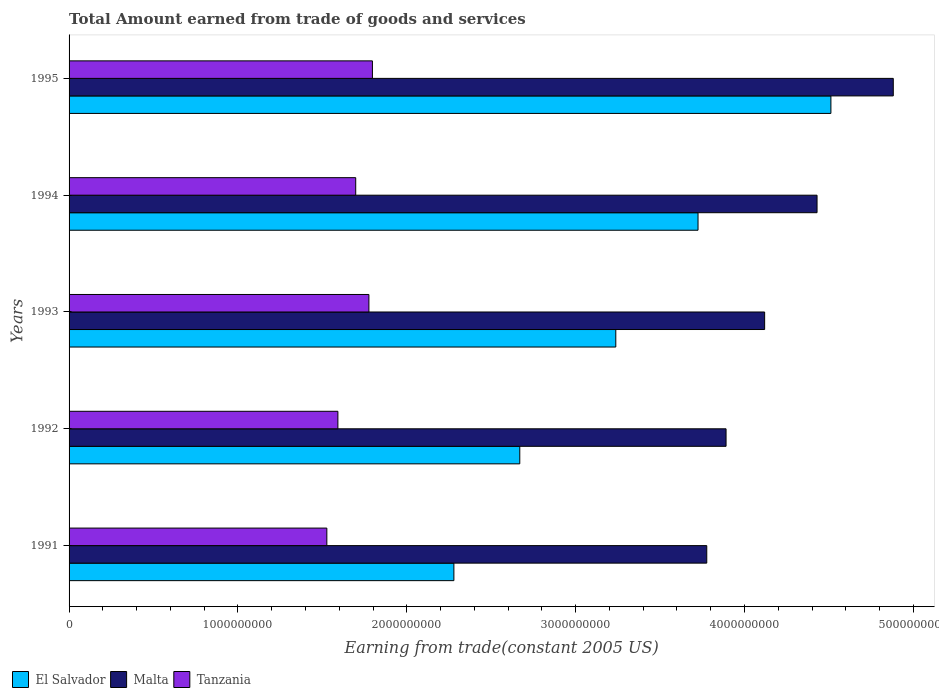How many different coloured bars are there?
Your answer should be very brief. 3. Are the number of bars per tick equal to the number of legend labels?
Offer a very short reply. Yes. What is the total amount earned by trading goods and services in El Salvador in 1992?
Provide a short and direct response. 2.67e+09. Across all years, what is the maximum total amount earned by trading goods and services in El Salvador?
Provide a succinct answer. 4.51e+09. Across all years, what is the minimum total amount earned by trading goods and services in Malta?
Provide a short and direct response. 3.78e+09. In which year was the total amount earned by trading goods and services in Malta minimum?
Offer a very short reply. 1991. What is the total total amount earned by trading goods and services in Malta in the graph?
Ensure brevity in your answer.  2.11e+1. What is the difference between the total amount earned by trading goods and services in El Salvador in 1993 and that in 1995?
Provide a succinct answer. -1.27e+09. What is the difference between the total amount earned by trading goods and services in El Salvador in 1991 and the total amount earned by trading goods and services in Tanzania in 1995?
Give a very brief answer. 4.82e+08. What is the average total amount earned by trading goods and services in Tanzania per year?
Provide a succinct answer. 1.68e+09. In the year 1991, what is the difference between the total amount earned by trading goods and services in Tanzania and total amount earned by trading goods and services in Malta?
Give a very brief answer. -2.25e+09. In how many years, is the total amount earned by trading goods and services in Malta greater than 4400000000 US$?
Keep it short and to the point. 2. What is the ratio of the total amount earned by trading goods and services in Malta in 1992 to that in 1993?
Your answer should be very brief. 0.94. What is the difference between the highest and the second highest total amount earned by trading goods and services in El Salvador?
Offer a very short reply. 7.87e+08. What is the difference between the highest and the lowest total amount earned by trading goods and services in El Salvador?
Your response must be concise. 2.23e+09. What does the 1st bar from the top in 1992 represents?
Provide a succinct answer. Tanzania. What does the 2nd bar from the bottom in 1993 represents?
Give a very brief answer. Malta. Are all the bars in the graph horizontal?
Your response must be concise. Yes. Does the graph contain any zero values?
Ensure brevity in your answer.  No. How many legend labels are there?
Offer a terse response. 3. How are the legend labels stacked?
Provide a short and direct response. Horizontal. What is the title of the graph?
Offer a very short reply. Total Amount earned from trade of goods and services. Does "South Sudan" appear as one of the legend labels in the graph?
Offer a very short reply. No. What is the label or title of the X-axis?
Offer a terse response. Earning from trade(constant 2005 US). What is the label or title of the Y-axis?
Your answer should be compact. Years. What is the Earning from trade(constant 2005 US) of El Salvador in 1991?
Offer a very short reply. 2.28e+09. What is the Earning from trade(constant 2005 US) in Malta in 1991?
Your answer should be compact. 3.78e+09. What is the Earning from trade(constant 2005 US) of Tanzania in 1991?
Offer a very short reply. 1.53e+09. What is the Earning from trade(constant 2005 US) of El Salvador in 1992?
Your answer should be compact. 2.67e+09. What is the Earning from trade(constant 2005 US) of Malta in 1992?
Your answer should be compact. 3.89e+09. What is the Earning from trade(constant 2005 US) in Tanzania in 1992?
Your answer should be very brief. 1.59e+09. What is the Earning from trade(constant 2005 US) in El Salvador in 1993?
Ensure brevity in your answer.  3.24e+09. What is the Earning from trade(constant 2005 US) in Malta in 1993?
Your answer should be very brief. 4.12e+09. What is the Earning from trade(constant 2005 US) of Tanzania in 1993?
Offer a terse response. 1.78e+09. What is the Earning from trade(constant 2005 US) in El Salvador in 1994?
Give a very brief answer. 3.72e+09. What is the Earning from trade(constant 2005 US) of Malta in 1994?
Offer a very short reply. 4.43e+09. What is the Earning from trade(constant 2005 US) in Tanzania in 1994?
Ensure brevity in your answer.  1.70e+09. What is the Earning from trade(constant 2005 US) of El Salvador in 1995?
Provide a short and direct response. 4.51e+09. What is the Earning from trade(constant 2005 US) of Malta in 1995?
Make the answer very short. 4.88e+09. What is the Earning from trade(constant 2005 US) of Tanzania in 1995?
Provide a succinct answer. 1.80e+09. Across all years, what is the maximum Earning from trade(constant 2005 US) of El Salvador?
Your response must be concise. 4.51e+09. Across all years, what is the maximum Earning from trade(constant 2005 US) of Malta?
Make the answer very short. 4.88e+09. Across all years, what is the maximum Earning from trade(constant 2005 US) of Tanzania?
Offer a terse response. 1.80e+09. Across all years, what is the minimum Earning from trade(constant 2005 US) in El Salvador?
Offer a terse response. 2.28e+09. Across all years, what is the minimum Earning from trade(constant 2005 US) of Malta?
Make the answer very short. 3.78e+09. Across all years, what is the minimum Earning from trade(constant 2005 US) in Tanzania?
Your response must be concise. 1.53e+09. What is the total Earning from trade(constant 2005 US) in El Salvador in the graph?
Offer a terse response. 1.64e+1. What is the total Earning from trade(constant 2005 US) in Malta in the graph?
Offer a terse response. 2.11e+1. What is the total Earning from trade(constant 2005 US) in Tanzania in the graph?
Make the answer very short. 8.39e+09. What is the difference between the Earning from trade(constant 2005 US) in El Salvador in 1991 and that in 1992?
Ensure brevity in your answer.  -3.90e+08. What is the difference between the Earning from trade(constant 2005 US) in Malta in 1991 and that in 1992?
Your response must be concise. -1.14e+08. What is the difference between the Earning from trade(constant 2005 US) of Tanzania in 1991 and that in 1992?
Provide a short and direct response. -6.54e+07. What is the difference between the Earning from trade(constant 2005 US) in El Salvador in 1991 and that in 1993?
Ensure brevity in your answer.  -9.59e+08. What is the difference between the Earning from trade(constant 2005 US) of Malta in 1991 and that in 1993?
Keep it short and to the point. -3.43e+08. What is the difference between the Earning from trade(constant 2005 US) in Tanzania in 1991 and that in 1993?
Keep it short and to the point. -2.49e+08. What is the difference between the Earning from trade(constant 2005 US) in El Salvador in 1991 and that in 1994?
Your answer should be compact. -1.45e+09. What is the difference between the Earning from trade(constant 2005 US) in Malta in 1991 and that in 1994?
Provide a short and direct response. -6.53e+08. What is the difference between the Earning from trade(constant 2005 US) in Tanzania in 1991 and that in 1994?
Offer a very short reply. -1.71e+08. What is the difference between the Earning from trade(constant 2005 US) of El Salvador in 1991 and that in 1995?
Offer a terse response. -2.23e+09. What is the difference between the Earning from trade(constant 2005 US) of Malta in 1991 and that in 1995?
Keep it short and to the point. -1.10e+09. What is the difference between the Earning from trade(constant 2005 US) of Tanzania in 1991 and that in 1995?
Offer a terse response. -2.70e+08. What is the difference between the Earning from trade(constant 2005 US) of El Salvador in 1992 and that in 1993?
Give a very brief answer. -5.69e+08. What is the difference between the Earning from trade(constant 2005 US) of Malta in 1992 and that in 1993?
Offer a terse response. -2.29e+08. What is the difference between the Earning from trade(constant 2005 US) in Tanzania in 1992 and that in 1993?
Make the answer very short. -1.84e+08. What is the difference between the Earning from trade(constant 2005 US) in El Salvador in 1992 and that in 1994?
Make the answer very short. -1.06e+09. What is the difference between the Earning from trade(constant 2005 US) of Malta in 1992 and that in 1994?
Your answer should be compact. -5.39e+08. What is the difference between the Earning from trade(constant 2005 US) in Tanzania in 1992 and that in 1994?
Provide a short and direct response. -1.06e+08. What is the difference between the Earning from trade(constant 2005 US) of El Salvador in 1992 and that in 1995?
Your answer should be very brief. -1.84e+09. What is the difference between the Earning from trade(constant 2005 US) of Malta in 1992 and that in 1995?
Keep it short and to the point. -9.90e+08. What is the difference between the Earning from trade(constant 2005 US) in Tanzania in 1992 and that in 1995?
Your answer should be compact. -2.05e+08. What is the difference between the Earning from trade(constant 2005 US) in El Salvador in 1993 and that in 1994?
Provide a short and direct response. -4.87e+08. What is the difference between the Earning from trade(constant 2005 US) in Malta in 1993 and that in 1994?
Keep it short and to the point. -3.10e+08. What is the difference between the Earning from trade(constant 2005 US) of Tanzania in 1993 and that in 1994?
Give a very brief answer. 7.81e+07. What is the difference between the Earning from trade(constant 2005 US) of El Salvador in 1993 and that in 1995?
Offer a terse response. -1.27e+09. What is the difference between the Earning from trade(constant 2005 US) of Malta in 1993 and that in 1995?
Keep it short and to the point. -7.62e+08. What is the difference between the Earning from trade(constant 2005 US) in Tanzania in 1993 and that in 1995?
Your answer should be very brief. -2.09e+07. What is the difference between the Earning from trade(constant 2005 US) of El Salvador in 1994 and that in 1995?
Keep it short and to the point. -7.87e+08. What is the difference between the Earning from trade(constant 2005 US) of Malta in 1994 and that in 1995?
Your answer should be compact. -4.51e+08. What is the difference between the Earning from trade(constant 2005 US) of Tanzania in 1994 and that in 1995?
Make the answer very short. -9.89e+07. What is the difference between the Earning from trade(constant 2005 US) of El Salvador in 1991 and the Earning from trade(constant 2005 US) of Malta in 1992?
Your response must be concise. -1.61e+09. What is the difference between the Earning from trade(constant 2005 US) of El Salvador in 1991 and the Earning from trade(constant 2005 US) of Tanzania in 1992?
Your answer should be compact. 6.87e+08. What is the difference between the Earning from trade(constant 2005 US) of Malta in 1991 and the Earning from trade(constant 2005 US) of Tanzania in 1992?
Your answer should be compact. 2.18e+09. What is the difference between the Earning from trade(constant 2005 US) of El Salvador in 1991 and the Earning from trade(constant 2005 US) of Malta in 1993?
Offer a very short reply. -1.84e+09. What is the difference between the Earning from trade(constant 2005 US) of El Salvador in 1991 and the Earning from trade(constant 2005 US) of Tanzania in 1993?
Offer a terse response. 5.03e+08. What is the difference between the Earning from trade(constant 2005 US) of Malta in 1991 and the Earning from trade(constant 2005 US) of Tanzania in 1993?
Keep it short and to the point. 2.00e+09. What is the difference between the Earning from trade(constant 2005 US) of El Salvador in 1991 and the Earning from trade(constant 2005 US) of Malta in 1994?
Offer a very short reply. -2.15e+09. What is the difference between the Earning from trade(constant 2005 US) of El Salvador in 1991 and the Earning from trade(constant 2005 US) of Tanzania in 1994?
Ensure brevity in your answer.  5.81e+08. What is the difference between the Earning from trade(constant 2005 US) in Malta in 1991 and the Earning from trade(constant 2005 US) in Tanzania in 1994?
Make the answer very short. 2.08e+09. What is the difference between the Earning from trade(constant 2005 US) of El Salvador in 1991 and the Earning from trade(constant 2005 US) of Malta in 1995?
Offer a terse response. -2.60e+09. What is the difference between the Earning from trade(constant 2005 US) in El Salvador in 1991 and the Earning from trade(constant 2005 US) in Tanzania in 1995?
Keep it short and to the point. 4.82e+08. What is the difference between the Earning from trade(constant 2005 US) in Malta in 1991 and the Earning from trade(constant 2005 US) in Tanzania in 1995?
Your response must be concise. 1.98e+09. What is the difference between the Earning from trade(constant 2005 US) of El Salvador in 1992 and the Earning from trade(constant 2005 US) of Malta in 1993?
Offer a very short reply. -1.45e+09. What is the difference between the Earning from trade(constant 2005 US) of El Salvador in 1992 and the Earning from trade(constant 2005 US) of Tanzania in 1993?
Keep it short and to the point. 8.94e+08. What is the difference between the Earning from trade(constant 2005 US) in Malta in 1992 and the Earning from trade(constant 2005 US) in Tanzania in 1993?
Offer a very short reply. 2.12e+09. What is the difference between the Earning from trade(constant 2005 US) of El Salvador in 1992 and the Earning from trade(constant 2005 US) of Malta in 1994?
Your answer should be compact. -1.76e+09. What is the difference between the Earning from trade(constant 2005 US) of El Salvador in 1992 and the Earning from trade(constant 2005 US) of Tanzania in 1994?
Keep it short and to the point. 9.72e+08. What is the difference between the Earning from trade(constant 2005 US) in Malta in 1992 and the Earning from trade(constant 2005 US) in Tanzania in 1994?
Give a very brief answer. 2.19e+09. What is the difference between the Earning from trade(constant 2005 US) of El Salvador in 1992 and the Earning from trade(constant 2005 US) of Malta in 1995?
Provide a short and direct response. -2.21e+09. What is the difference between the Earning from trade(constant 2005 US) of El Salvador in 1992 and the Earning from trade(constant 2005 US) of Tanzania in 1995?
Offer a terse response. 8.73e+08. What is the difference between the Earning from trade(constant 2005 US) of Malta in 1992 and the Earning from trade(constant 2005 US) of Tanzania in 1995?
Offer a very short reply. 2.09e+09. What is the difference between the Earning from trade(constant 2005 US) in El Salvador in 1993 and the Earning from trade(constant 2005 US) in Malta in 1994?
Your answer should be compact. -1.19e+09. What is the difference between the Earning from trade(constant 2005 US) in El Salvador in 1993 and the Earning from trade(constant 2005 US) in Tanzania in 1994?
Offer a very short reply. 1.54e+09. What is the difference between the Earning from trade(constant 2005 US) of Malta in 1993 and the Earning from trade(constant 2005 US) of Tanzania in 1994?
Ensure brevity in your answer.  2.42e+09. What is the difference between the Earning from trade(constant 2005 US) in El Salvador in 1993 and the Earning from trade(constant 2005 US) in Malta in 1995?
Offer a terse response. -1.64e+09. What is the difference between the Earning from trade(constant 2005 US) of El Salvador in 1993 and the Earning from trade(constant 2005 US) of Tanzania in 1995?
Keep it short and to the point. 1.44e+09. What is the difference between the Earning from trade(constant 2005 US) in Malta in 1993 and the Earning from trade(constant 2005 US) in Tanzania in 1995?
Your answer should be compact. 2.32e+09. What is the difference between the Earning from trade(constant 2005 US) of El Salvador in 1994 and the Earning from trade(constant 2005 US) of Malta in 1995?
Offer a very short reply. -1.16e+09. What is the difference between the Earning from trade(constant 2005 US) in El Salvador in 1994 and the Earning from trade(constant 2005 US) in Tanzania in 1995?
Ensure brevity in your answer.  1.93e+09. What is the difference between the Earning from trade(constant 2005 US) in Malta in 1994 and the Earning from trade(constant 2005 US) in Tanzania in 1995?
Provide a succinct answer. 2.63e+09. What is the average Earning from trade(constant 2005 US) of El Salvador per year?
Your response must be concise. 3.28e+09. What is the average Earning from trade(constant 2005 US) in Malta per year?
Offer a very short reply. 4.22e+09. What is the average Earning from trade(constant 2005 US) of Tanzania per year?
Keep it short and to the point. 1.68e+09. In the year 1991, what is the difference between the Earning from trade(constant 2005 US) of El Salvador and Earning from trade(constant 2005 US) of Malta?
Provide a succinct answer. -1.50e+09. In the year 1991, what is the difference between the Earning from trade(constant 2005 US) in El Salvador and Earning from trade(constant 2005 US) in Tanzania?
Make the answer very short. 7.52e+08. In the year 1991, what is the difference between the Earning from trade(constant 2005 US) in Malta and Earning from trade(constant 2005 US) in Tanzania?
Offer a very short reply. 2.25e+09. In the year 1992, what is the difference between the Earning from trade(constant 2005 US) of El Salvador and Earning from trade(constant 2005 US) of Malta?
Ensure brevity in your answer.  -1.22e+09. In the year 1992, what is the difference between the Earning from trade(constant 2005 US) of El Salvador and Earning from trade(constant 2005 US) of Tanzania?
Your answer should be compact. 1.08e+09. In the year 1992, what is the difference between the Earning from trade(constant 2005 US) in Malta and Earning from trade(constant 2005 US) in Tanzania?
Make the answer very short. 2.30e+09. In the year 1993, what is the difference between the Earning from trade(constant 2005 US) of El Salvador and Earning from trade(constant 2005 US) of Malta?
Your answer should be very brief. -8.81e+08. In the year 1993, what is the difference between the Earning from trade(constant 2005 US) of El Salvador and Earning from trade(constant 2005 US) of Tanzania?
Your response must be concise. 1.46e+09. In the year 1993, what is the difference between the Earning from trade(constant 2005 US) in Malta and Earning from trade(constant 2005 US) in Tanzania?
Give a very brief answer. 2.34e+09. In the year 1994, what is the difference between the Earning from trade(constant 2005 US) in El Salvador and Earning from trade(constant 2005 US) in Malta?
Ensure brevity in your answer.  -7.05e+08. In the year 1994, what is the difference between the Earning from trade(constant 2005 US) of El Salvador and Earning from trade(constant 2005 US) of Tanzania?
Your response must be concise. 2.03e+09. In the year 1994, what is the difference between the Earning from trade(constant 2005 US) of Malta and Earning from trade(constant 2005 US) of Tanzania?
Provide a short and direct response. 2.73e+09. In the year 1995, what is the difference between the Earning from trade(constant 2005 US) in El Salvador and Earning from trade(constant 2005 US) in Malta?
Provide a short and direct response. -3.69e+08. In the year 1995, what is the difference between the Earning from trade(constant 2005 US) of El Salvador and Earning from trade(constant 2005 US) of Tanzania?
Keep it short and to the point. 2.72e+09. In the year 1995, what is the difference between the Earning from trade(constant 2005 US) in Malta and Earning from trade(constant 2005 US) in Tanzania?
Give a very brief answer. 3.08e+09. What is the ratio of the Earning from trade(constant 2005 US) of El Salvador in 1991 to that in 1992?
Provide a short and direct response. 0.85. What is the ratio of the Earning from trade(constant 2005 US) in Malta in 1991 to that in 1992?
Your answer should be compact. 0.97. What is the ratio of the Earning from trade(constant 2005 US) in Tanzania in 1991 to that in 1992?
Offer a terse response. 0.96. What is the ratio of the Earning from trade(constant 2005 US) in El Salvador in 1991 to that in 1993?
Keep it short and to the point. 0.7. What is the ratio of the Earning from trade(constant 2005 US) in Malta in 1991 to that in 1993?
Provide a succinct answer. 0.92. What is the ratio of the Earning from trade(constant 2005 US) in Tanzania in 1991 to that in 1993?
Offer a very short reply. 0.86. What is the ratio of the Earning from trade(constant 2005 US) of El Salvador in 1991 to that in 1994?
Keep it short and to the point. 0.61. What is the ratio of the Earning from trade(constant 2005 US) in Malta in 1991 to that in 1994?
Keep it short and to the point. 0.85. What is the ratio of the Earning from trade(constant 2005 US) of Tanzania in 1991 to that in 1994?
Your response must be concise. 0.9. What is the ratio of the Earning from trade(constant 2005 US) of El Salvador in 1991 to that in 1995?
Your answer should be very brief. 0.51. What is the ratio of the Earning from trade(constant 2005 US) in Malta in 1991 to that in 1995?
Keep it short and to the point. 0.77. What is the ratio of the Earning from trade(constant 2005 US) of Tanzania in 1991 to that in 1995?
Provide a short and direct response. 0.85. What is the ratio of the Earning from trade(constant 2005 US) in El Salvador in 1992 to that in 1993?
Your answer should be very brief. 0.82. What is the ratio of the Earning from trade(constant 2005 US) in Malta in 1992 to that in 1993?
Your response must be concise. 0.94. What is the ratio of the Earning from trade(constant 2005 US) in Tanzania in 1992 to that in 1993?
Keep it short and to the point. 0.9. What is the ratio of the Earning from trade(constant 2005 US) in El Salvador in 1992 to that in 1994?
Offer a very short reply. 0.72. What is the ratio of the Earning from trade(constant 2005 US) of Malta in 1992 to that in 1994?
Offer a terse response. 0.88. What is the ratio of the Earning from trade(constant 2005 US) of Tanzania in 1992 to that in 1994?
Your response must be concise. 0.94. What is the ratio of the Earning from trade(constant 2005 US) in El Salvador in 1992 to that in 1995?
Offer a very short reply. 0.59. What is the ratio of the Earning from trade(constant 2005 US) of Malta in 1992 to that in 1995?
Offer a very short reply. 0.8. What is the ratio of the Earning from trade(constant 2005 US) in Tanzania in 1992 to that in 1995?
Offer a terse response. 0.89. What is the ratio of the Earning from trade(constant 2005 US) of El Salvador in 1993 to that in 1994?
Your answer should be very brief. 0.87. What is the ratio of the Earning from trade(constant 2005 US) of Malta in 1993 to that in 1994?
Offer a terse response. 0.93. What is the ratio of the Earning from trade(constant 2005 US) of Tanzania in 1993 to that in 1994?
Keep it short and to the point. 1.05. What is the ratio of the Earning from trade(constant 2005 US) in El Salvador in 1993 to that in 1995?
Keep it short and to the point. 0.72. What is the ratio of the Earning from trade(constant 2005 US) in Malta in 1993 to that in 1995?
Offer a terse response. 0.84. What is the ratio of the Earning from trade(constant 2005 US) in Tanzania in 1993 to that in 1995?
Keep it short and to the point. 0.99. What is the ratio of the Earning from trade(constant 2005 US) of El Salvador in 1994 to that in 1995?
Your response must be concise. 0.83. What is the ratio of the Earning from trade(constant 2005 US) of Malta in 1994 to that in 1995?
Your answer should be very brief. 0.91. What is the ratio of the Earning from trade(constant 2005 US) in Tanzania in 1994 to that in 1995?
Offer a terse response. 0.94. What is the difference between the highest and the second highest Earning from trade(constant 2005 US) in El Salvador?
Your response must be concise. 7.87e+08. What is the difference between the highest and the second highest Earning from trade(constant 2005 US) of Malta?
Make the answer very short. 4.51e+08. What is the difference between the highest and the second highest Earning from trade(constant 2005 US) in Tanzania?
Offer a very short reply. 2.09e+07. What is the difference between the highest and the lowest Earning from trade(constant 2005 US) of El Salvador?
Provide a succinct answer. 2.23e+09. What is the difference between the highest and the lowest Earning from trade(constant 2005 US) in Malta?
Provide a short and direct response. 1.10e+09. What is the difference between the highest and the lowest Earning from trade(constant 2005 US) of Tanzania?
Provide a short and direct response. 2.70e+08. 